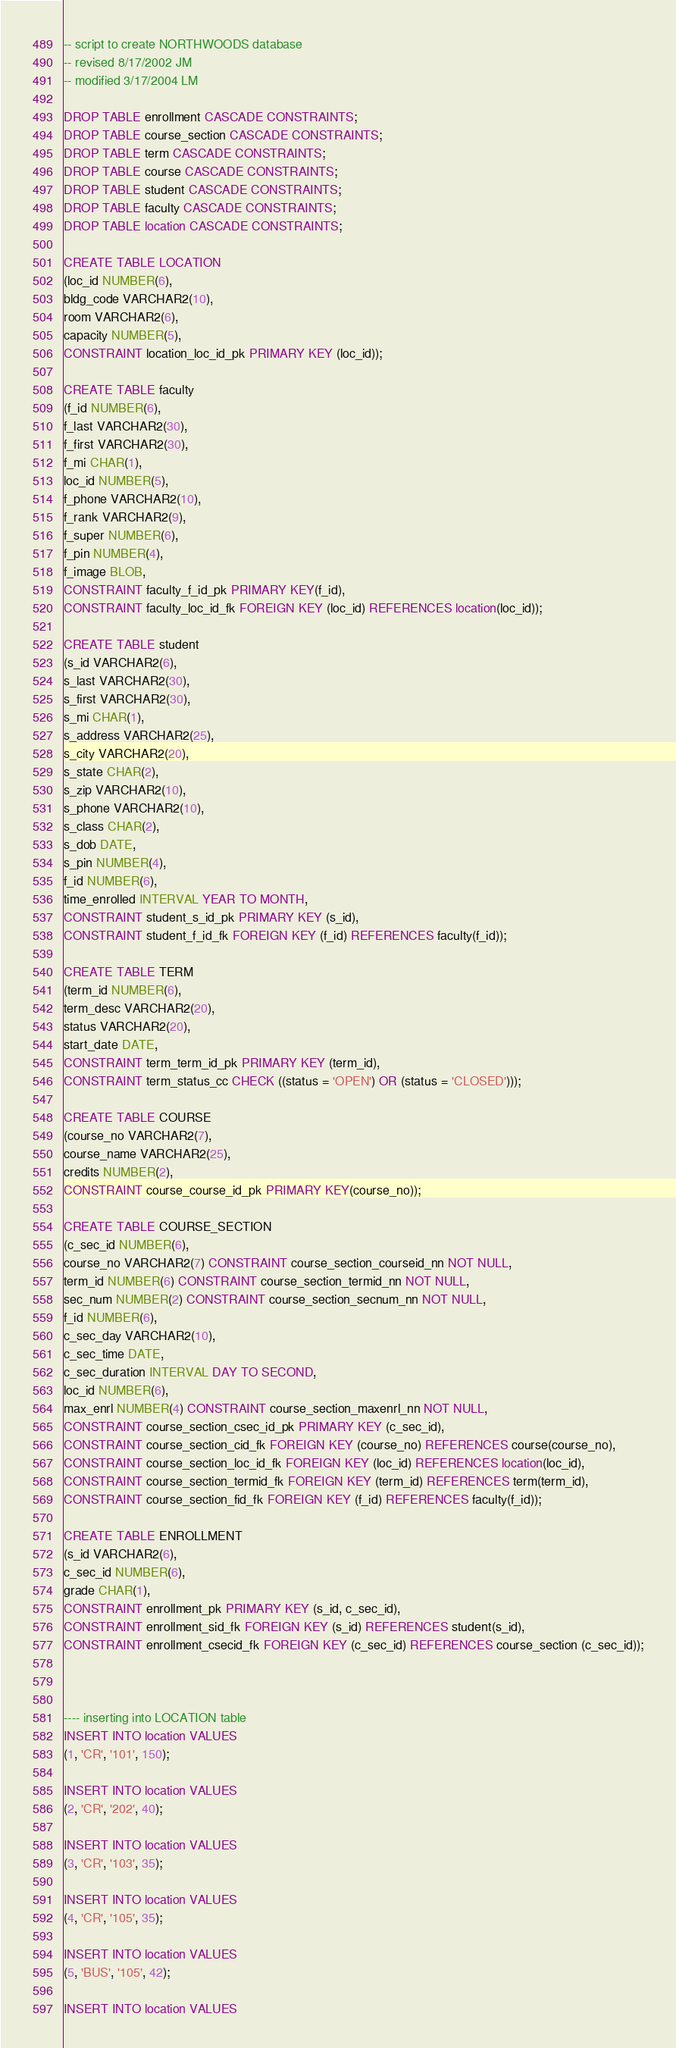<code> <loc_0><loc_0><loc_500><loc_500><_SQL_>-- script to create NORTHWOODS database
-- revised 8/17/2002 JM 
-- modified 3/17/2004 LM

DROP TABLE enrollment CASCADE CONSTRAINTS;
DROP TABLE course_section CASCADE CONSTRAINTS;
DROP TABLE term CASCADE CONSTRAINTS;
DROP TABLE course CASCADE CONSTRAINTS;
DROP TABLE student CASCADE CONSTRAINTS;
DROP TABLE faculty CASCADE CONSTRAINTS;
DROP TABLE location CASCADE CONSTRAINTS;

CREATE TABLE LOCATION
(loc_id NUMBER(6),
bldg_code VARCHAR2(10),
room VARCHAR2(6),
capacity NUMBER(5), 
CONSTRAINT location_loc_id_pk PRIMARY KEY (loc_id));

CREATE TABLE faculty
(f_id NUMBER(6),
f_last VARCHAR2(30),
f_first VARCHAR2(30),
f_mi CHAR(1),
loc_id NUMBER(5),
f_phone VARCHAR2(10),
f_rank VARCHAR2(9),
f_super NUMBER(6), 
f_pin NUMBER(4),
f_image BLOB, 
CONSTRAINT faculty_f_id_pk PRIMARY KEY(f_id),
CONSTRAINT faculty_loc_id_fk FOREIGN KEY (loc_id) REFERENCES location(loc_id));

CREATE TABLE student
(s_id VARCHAR2(6),
s_last VARCHAR2(30),
s_first VARCHAR2(30),
s_mi CHAR(1),
s_address VARCHAR2(25),
s_city VARCHAR2(20),
s_state CHAR(2),
s_zip VARCHAR2(10),
s_phone VARCHAR2(10),
s_class CHAR(2),
s_dob DATE,
s_pin NUMBER(4),
f_id NUMBER(6),
time_enrolled INTERVAL YEAR TO MONTH,
CONSTRAINT student_s_id_pk PRIMARY KEY (s_id),
CONSTRAINT student_f_id_fk FOREIGN KEY (f_id) REFERENCES faculty(f_id));

CREATE TABLE TERM
(term_id NUMBER(6),
term_desc VARCHAR2(20),
status VARCHAR2(20),
start_date DATE,
CONSTRAINT term_term_id_pk PRIMARY KEY (term_id),
CONSTRAINT term_status_cc CHECK ((status = 'OPEN') OR (status = 'CLOSED')));

CREATE TABLE COURSE
(course_no VARCHAR2(7),
course_name VARCHAR2(25),
credits NUMBER(2),
CONSTRAINT course_course_id_pk PRIMARY KEY(course_no));

CREATE TABLE COURSE_SECTION
(c_sec_id NUMBER(6),
course_no VARCHAR2(7) CONSTRAINT course_section_courseid_nn NOT NULL,
term_id NUMBER(6) CONSTRAINT course_section_termid_nn NOT NULL,
sec_num NUMBER(2) CONSTRAINT course_section_secnum_nn NOT NULL,
f_id NUMBER(6),
c_sec_day VARCHAR2(10),
c_sec_time DATE,
c_sec_duration INTERVAL DAY TO SECOND,
loc_id NUMBER(6),
max_enrl NUMBER(4) CONSTRAINT course_section_maxenrl_nn NOT NULL,
CONSTRAINT course_section_csec_id_pk PRIMARY KEY (c_sec_id),
CONSTRAINT course_section_cid_fk FOREIGN KEY (course_no) REFERENCES course(course_no), 	
CONSTRAINT course_section_loc_id_fk FOREIGN KEY (loc_id) REFERENCES location(loc_id),
CONSTRAINT course_section_termid_fk FOREIGN KEY (term_id) REFERENCES term(term_id),
CONSTRAINT course_section_fid_fk FOREIGN KEY (f_id) REFERENCES faculty(f_id));

CREATE TABLE ENROLLMENT
(s_id VARCHAR2(6),
c_sec_id NUMBER(6),
grade CHAR(1),
CONSTRAINT enrollment_pk PRIMARY KEY (s_id, c_sec_id),
CONSTRAINT enrollment_sid_fk FOREIGN KEY (s_id) REFERENCES student(s_id),
CONSTRAINT enrollment_csecid_fk FOREIGN KEY (c_sec_id) REFERENCES course_section (c_sec_id));



---- inserting into LOCATION table
INSERT INTO location VALUES
(1, 'CR', '101', 150);

INSERT INTO location VALUES
(2, 'CR', '202', 40);

INSERT INTO location VALUES
(3, 'CR', '103', 35);

INSERT INTO location VALUES
(4, 'CR', '105', 35);

INSERT INTO location VALUES
(5, 'BUS', '105', 42);

INSERT INTO location VALUES</code> 